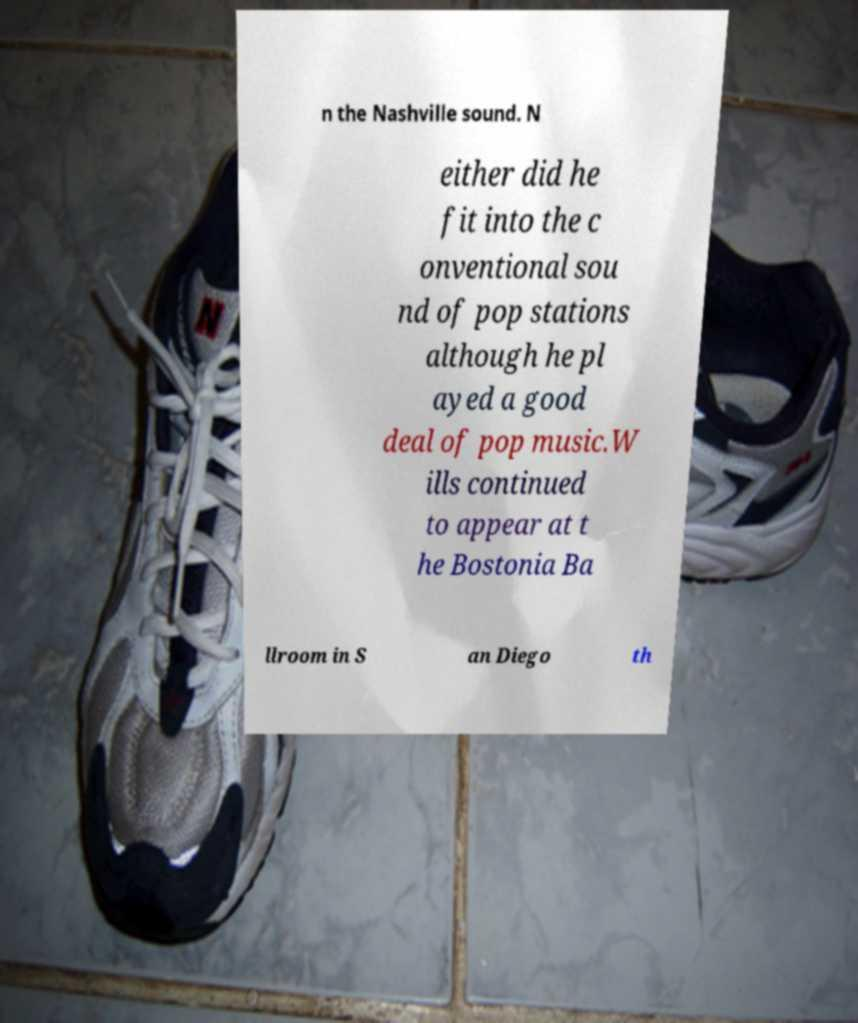Can you accurately transcribe the text from the provided image for me? n the Nashville sound. N either did he fit into the c onventional sou nd of pop stations although he pl ayed a good deal of pop music.W ills continued to appear at t he Bostonia Ba llroom in S an Diego th 